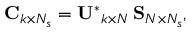Convert formula to latex. <formula><loc_0><loc_0><loc_500><loc_500>C _ { k \times N _ { s } } = U ^ { * } _ { k \times N } \, S _ { N \times N _ { s } } ,</formula> 